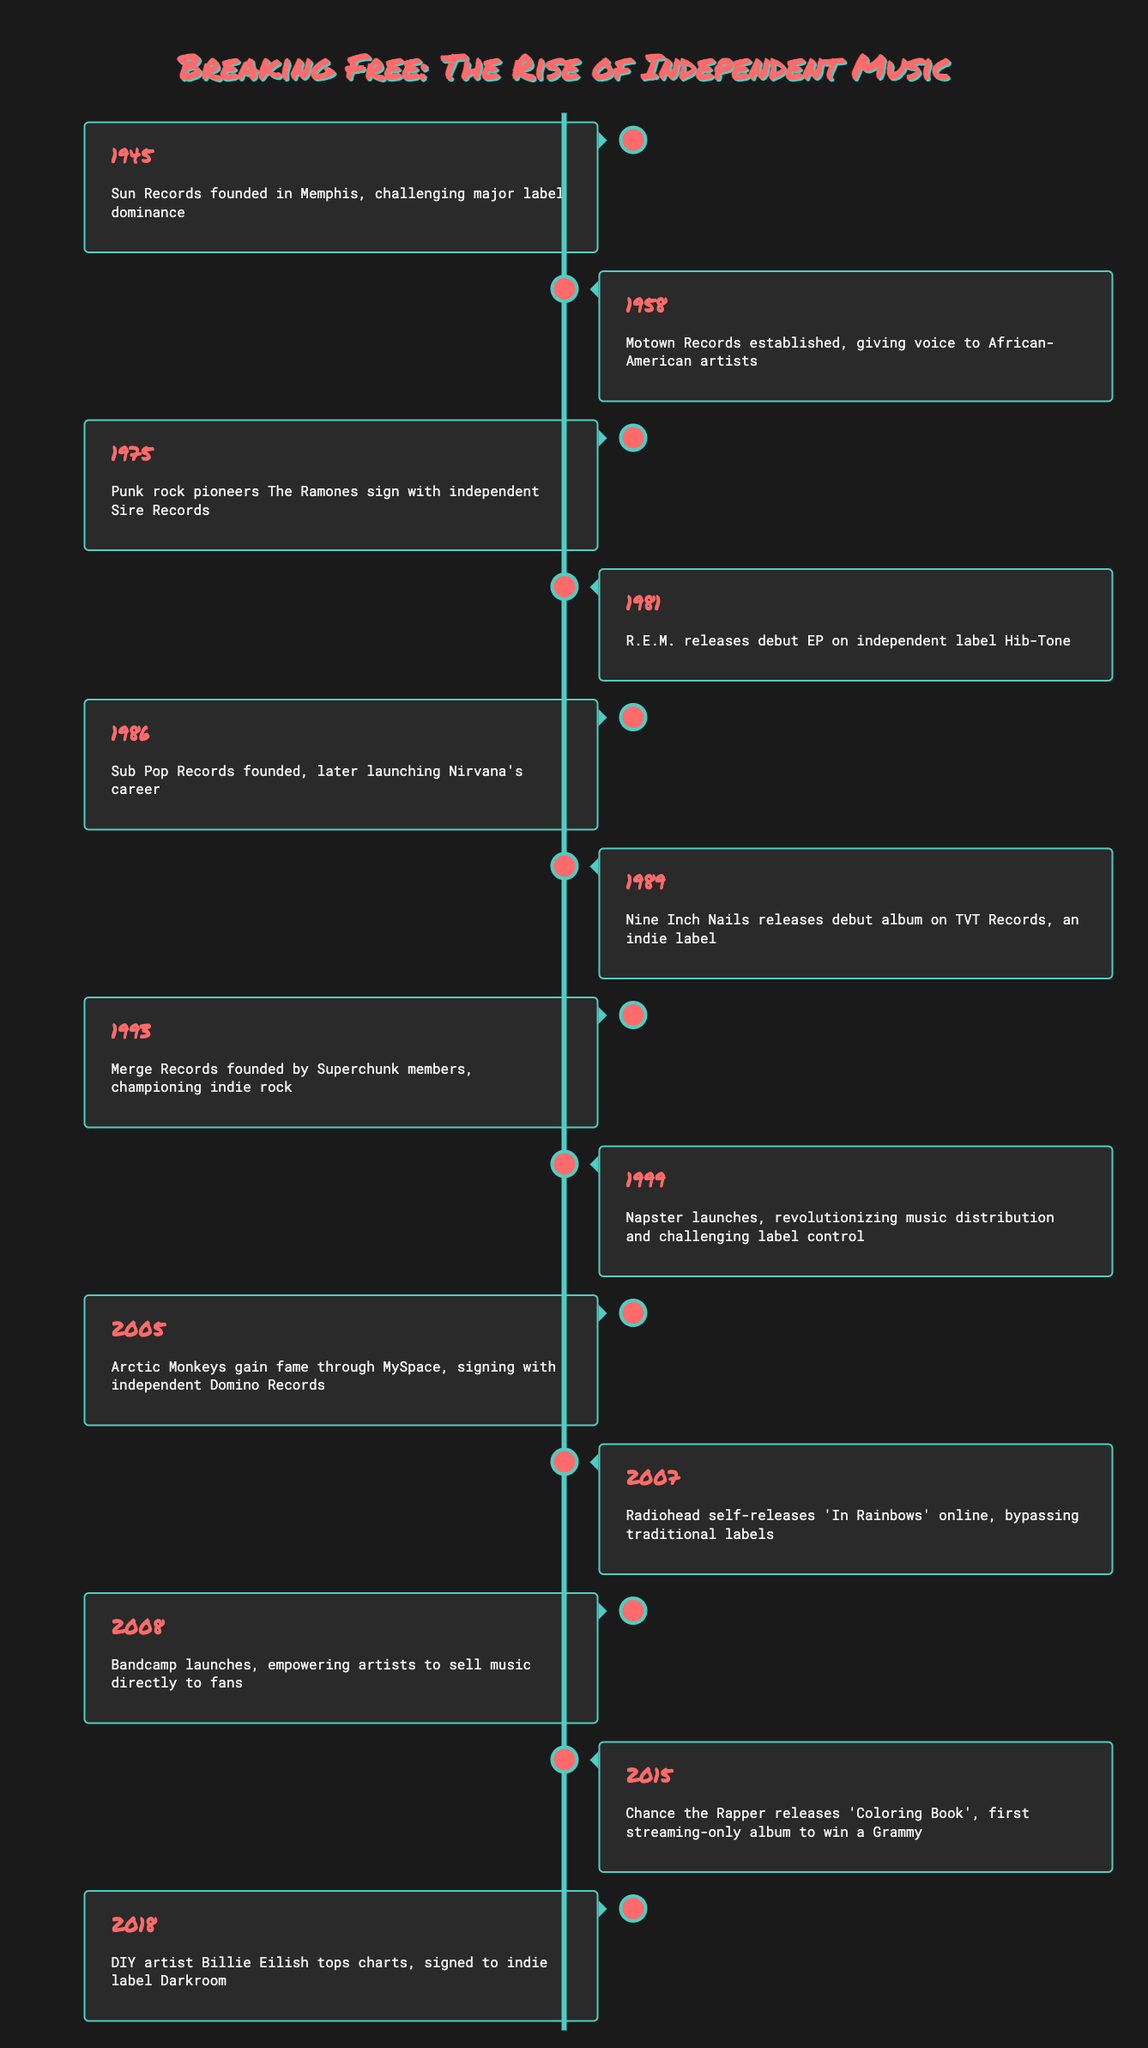What significant event in music history happened in 1945? According to the table, in 1945, Sun Records was founded in Memphis, which marked a challenge to major label dominance.
Answer: Sun Records founded in Memphis, challenging major label dominance Which artist signed with an independent label in 2005? The table states that in 2005, Arctic Monkeys gained fame through MySpace and subsequently signed with independent Domino Records.
Answer: Arctic Monkeys What was the last milestone listed in the timeline? Reviewing the table shows that the last milestone is from 2018, where DIY artist Billie Eilish topped the charts and was signed to indie label Darkroom.
Answer: DIY artist Billie Eilish tops charts, signed to indie label Darkroom How many years apart are the events found in 1986 and 1993 in the timeline? The year 1986 marks the founding of Sub Pop Records, and 1993 is when Merge Records was founded. The difference in years is 1993 - 1986 = 7 years.
Answer: 7 years Did Motown Records get established before or after the founding of Sub Pop Records? According to the table, Motown Records was established in 1958 and Sub Pop Records was founded in 1986, making Motown Records established before Sub Pop Records.
Answer: Before Which event represents a shift towards artists controlling their music distribution? The timeline highlights the launch of Napster in 1999 as a pivotal moment that revolutionized music distribution and challenged traditional label control.
Answer: Napster launches, revolutionizing music distribution and challenging label control What event represents the success of independent artists in the streaming era? In 2015, Chance the Rapper released 'Coloring Book', which was the first streaming-only album to win a Grammy, illustrating the success of independent artists in the streaming era.
Answer: Chance the Rapper releases 'Coloring Book', first streaming-only album to win a Grammy Who were the founding members of Merge Records? The table indicates that Merge Records was founded by members of the band Superchunk, marking a significant contribution to the indie rock scene.
Answer: Members of Superchunk What is the first listed event related to independent music labels in this timeline? The timeline starts with the founding of Sun Records in 1945, which is the first listed event regarding independent music labels.
Answer: Sun Records founded in Memphis, challenging major label dominance 